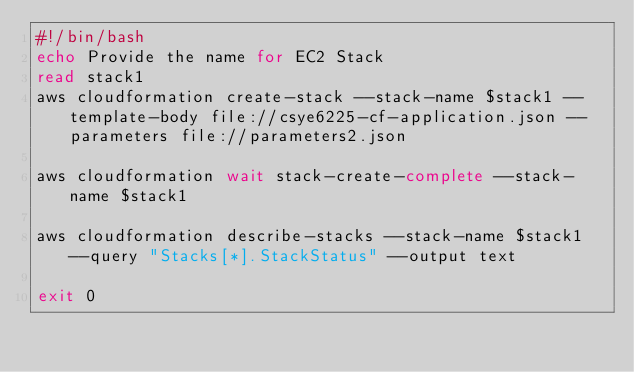<code> <loc_0><loc_0><loc_500><loc_500><_Bash_>#!/bin/bash
echo Provide the name for EC2 Stack
read stack1
aws cloudformation create-stack --stack-name $stack1 --template-body file://csye6225-cf-application.json --parameters file://parameters2.json

aws cloudformation wait stack-create-complete --stack-name $stack1

aws cloudformation describe-stacks --stack-name $stack1 --query "Stacks[*].StackStatus" --output text

exit 0
</code> 